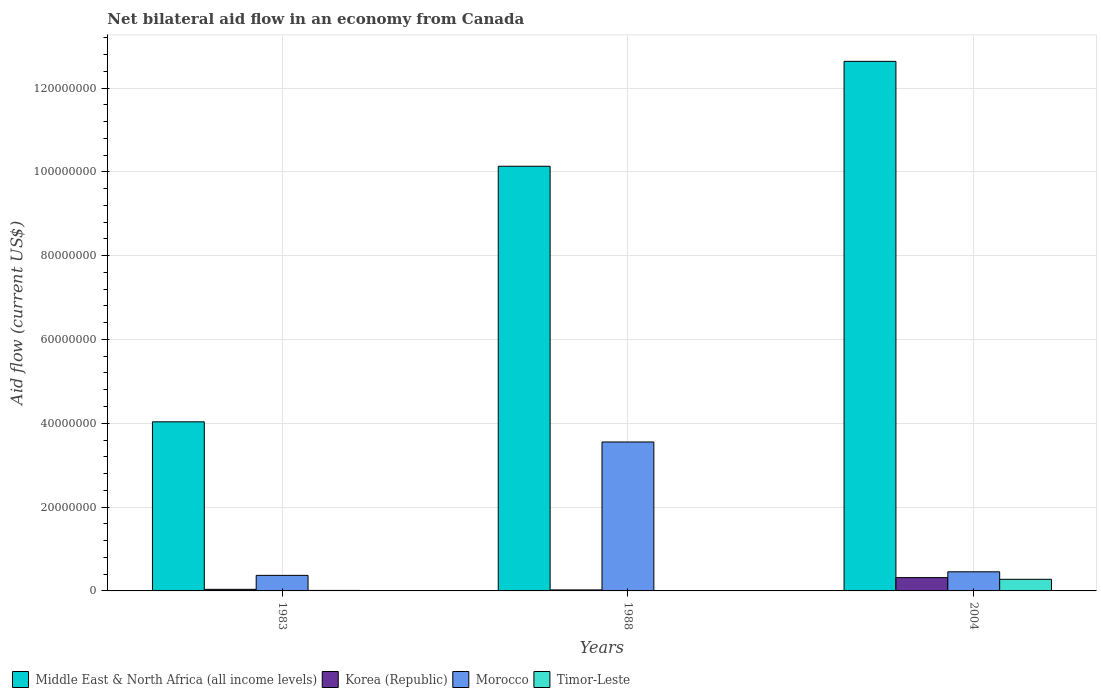How many different coloured bars are there?
Make the answer very short. 4. How many groups of bars are there?
Offer a very short reply. 3. Are the number of bars per tick equal to the number of legend labels?
Your answer should be compact. Yes. How many bars are there on the 1st tick from the right?
Provide a succinct answer. 4. What is the label of the 1st group of bars from the left?
Offer a terse response. 1983. What is the net bilateral aid flow in Korea (Republic) in 2004?
Your answer should be very brief. 3.18e+06. Across all years, what is the maximum net bilateral aid flow in Korea (Republic)?
Offer a terse response. 3.18e+06. What is the total net bilateral aid flow in Korea (Republic) in the graph?
Keep it short and to the point. 3.80e+06. What is the difference between the net bilateral aid flow in Morocco in 1983 and that in 1988?
Keep it short and to the point. -3.18e+07. What is the difference between the net bilateral aid flow in Timor-Leste in 1983 and the net bilateral aid flow in Korea (Republic) in 2004?
Your answer should be compact. -3.06e+06. What is the average net bilateral aid flow in Korea (Republic) per year?
Your answer should be compact. 1.27e+06. In the year 1988, what is the difference between the net bilateral aid flow in Middle East & North Africa (all income levels) and net bilateral aid flow in Morocco?
Your answer should be very brief. 6.58e+07. What is the ratio of the net bilateral aid flow in Middle East & North Africa (all income levels) in 1983 to that in 1988?
Offer a very short reply. 0.4. Is the net bilateral aid flow in Timor-Leste in 1988 less than that in 2004?
Keep it short and to the point. Yes. Is the difference between the net bilateral aid flow in Middle East & North Africa (all income levels) in 1983 and 1988 greater than the difference between the net bilateral aid flow in Morocco in 1983 and 1988?
Provide a succinct answer. No. What is the difference between the highest and the second highest net bilateral aid flow in Morocco?
Keep it short and to the point. 3.10e+07. What is the difference between the highest and the lowest net bilateral aid flow in Timor-Leste?
Your response must be concise. 2.75e+06. Is the sum of the net bilateral aid flow in Korea (Republic) in 1983 and 2004 greater than the maximum net bilateral aid flow in Middle East & North Africa (all income levels) across all years?
Your answer should be compact. No. Is it the case that in every year, the sum of the net bilateral aid flow in Korea (Republic) and net bilateral aid flow in Morocco is greater than the sum of net bilateral aid flow in Middle East & North Africa (all income levels) and net bilateral aid flow in Timor-Leste?
Ensure brevity in your answer.  No. What does the 1st bar from the left in 1988 represents?
Ensure brevity in your answer.  Middle East & North Africa (all income levels). What does the 1st bar from the right in 1988 represents?
Provide a succinct answer. Timor-Leste. Is it the case that in every year, the sum of the net bilateral aid flow in Morocco and net bilateral aid flow in Timor-Leste is greater than the net bilateral aid flow in Middle East & North Africa (all income levels)?
Ensure brevity in your answer.  No. How many bars are there?
Offer a terse response. 12. Are all the bars in the graph horizontal?
Give a very brief answer. No. What is the difference between two consecutive major ticks on the Y-axis?
Keep it short and to the point. 2.00e+07. Are the values on the major ticks of Y-axis written in scientific E-notation?
Give a very brief answer. No. Does the graph contain any zero values?
Provide a short and direct response. No. Does the graph contain grids?
Your answer should be very brief. Yes. Where does the legend appear in the graph?
Your response must be concise. Bottom left. How many legend labels are there?
Keep it short and to the point. 4. How are the legend labels stacked?
Provide a succinct answer. Horizontal. What is the title of the graph?
Offer a terse response. Net bilateral aid flow in an economy from Canada. What is the Aid flow (current US$) in Middle East & North Africa (all income levels) in 1983?
Keep it short and to the point. 4.04e+07. What is the Aid flow (current US$) in Morocco in 1983?
Make the answer very short. 3.71e+06. What is the Aid flow (current US$) of Middle East & North Africa (all income levels) in 1988?
Provide a succinct answer. 1.01e+08. What is the Aid flow (current US$) in Korea (Republic) in 1988?
Your answer should be very brief. 2.40e+05. What is the Aid flow (current US$) of Morocco in 1988?
Your answer should be very brief. 3.55e+07. What is the Aid flow (current US$) of Middle East & North Africa (all income levels) in 2004?
Provide a short and direct response. 1.26e+08. What is the Aid flow (current US$) in Korea (Republic) in 2004?
Make the answer very short. 3.18e+06. What is the Aid flow (current US$) in Morocco in 2004?
Give a very brief answer. 4.56e+06. What is the Aid flow (current US$) in Timor-Leste in 2004?
Provide a succinct answer. 2.77e+06. Across all years, what is the maximum Aid flow (current US$) of Middle East & North Africa (all income levels)?
Keep it short and to the point. 1.26e+08. Across all years, what is the maximum Aid flow (current US$) of Korea (Republic)?
Give a very brief answer. 3.18e+06. Across all years, what is the maximum Aid flow (current US$) of Morocco?
Provide a succinct answer. 3.55e+07. Across all years, what is the maximum Aid flow (current US$) in Timor-Leste?
Your answer should be very brief. 2.77e+06. Across all years, what is the minimum Aid flow (current US$) in Middle East & North Africa (all income levels)?
Keep it short and to the point. 4.04e+07. Across all years, what is the minimum Aid flow (current US$) of Morocco?
Your answer should be very brief. 3.71e+06. What is the total Aid flow (current US$) of Middle East & North Africa (all income levels) in the graph?
Give a very brief answer. 2.68e+08. What is the total Aid flow (current US$) in Korea (Republic) in the graph?
Ensure brevity in your answer.  3.80e+06. What is the total Aid flow (current US$) of Morocco in the graph?
Your answer should be very brief. 4.38e+07. What is the total Aid flow (current US$) of Timor-Leste in the graph?
Your response must be concise. 2.91e+06. What is the difference between the Aid flow (current US$) of Middle East & North Africa (all income levels) in 1983 and that in 1988?
Your response must be concise. -6.10e+07. What is the difference between the Aid flow (current US$) of Korea (Republic) in 1983 and that in 1988?
Keep it short and to the point. 1.40e+05. What is the difference between the Aid flow (current US$) in Morocco in 1983 and that in 1988?
Offer a very short reply. -3.18e+07. What is the difference between the Aid flow (current US$) in Middle East & North Africa (all income levels) in 1983 and that in 2004?
Give a very brief answer. -8.60e+07. What is the difference between the Aid flow (current US$) of Korea (Republic) in 1983 and that in 2004?
Offer a very short reply. -2.80e+06. What is the difference between the Aid flow (current US$) of Morocco in 1983 and that in 2004?
Offer a terse response. -8.50e+05. What is the difference between the Aid flow (current US$) in Timor-Leste in 1983 and that in 2004?
Provide a succinct answer. -2.65e+06. What is the difference between the Aid flow (current US$) of Middle East & North Africa (all income levels) in 1988 and that in 2004?
Make the answer very short. -2.50e+07. What is the difference between the Aid flow (current US$) of Korea (Republic) in 1988 and that in 2004?
Provide a short and direct response. -2.94e+06. What is the difference between the Aid flow (current US$) in Morocco in 1988 and that in 2004?
Provide a succinct answer. 3.10e+07. What is the difference between the Aid flow (current US$) of Timor-Leste in 1988 and that in 2004?
Your answer should be compact. -2.75e+06. What is the difference between the Aid flow (current US$) in Middle East & North Africa (all income levels) in 1983 and the Aid flow (current US$) in Korea (Republic) in 1988?
Provide a short and direct response. 4.01e+07. What is the difference between the Aid flow (current US$) of Middle East & North Africa (all income levels) in 1983 and the Aid flow (current US$) of Morocco in 1988?
Offer a very short reply. 4.81e+06. What is the difference between the Aid flow (current US$) in Middle East & North Africa (all income levels) in 1983 and the Aid flow (current US$) in Timor-Leste in 1988?
Keep it short and to the point. 4.03e+07. What is the difference between the Aid flow (current US$) in Korea (Republic) in 1983 and the Aid flow (current US$) in Morocco in 1988?
Your answer should be very brief. -3.52e+07. What is the difference between the Aid flow (current US$) of Korea (Republic) in 1983 and the Aid flow (current US$) of Timor-Leste in 1988?
Keep it short and to the point. 3.60e+05. What is the difference between the Aid flow (current US$) of Morocco in 1983 and the Aid flow (current US$) of Timor-Leste in 1988?
Ensure brevity in your answer.  3.69e+06. What is the difference between the Aid flow (current US$) of Middle East & North Africa (all income levels) in 1983 and the Aid flow (current US$) of Korea (Republic) in 2004?
Keep it short and to the point. 3.72e+07. What is the difference between the Aid flow (current US$) in Middle East & North Africa (all income levels) in 1983 and the Aid flow (current US$) in Morocco in 2004?
Keep it short and to the point. 3.58e+07. What is the difference between the Aid flow (current US$) of Middle East & North Africa (all income levels) in 1983 and the Aid flow (current US$) of Timor-Leste in 2004?
Provide a short and direct response. 3.76e+07. What is the difference between the Aid flow (current US$) in Korea (Republic) in 1983 and the Aid flow (current US$) in Morocco in 2004?
Your answer should be compact. -4.18e+06. What is the difference between the Aid flow (current US$) of Korea (Republic) in 1983 and the Aid flow (current US$) of Timor-Leste in 2004?
Your answer should be compact. -2.39e+06. What is the difference between the Aid flow (current US$) of Morocco in 1983 and the Aid flow (current US$) of Timor-Leste in 2004?
Provide a short and direct response. 9.40e+05. What is the difference between the Aid flow (current US$) in Middle East & North Africa (all income levels) in 1988 and the Aid flow (current US$) in Korea (Republic) in 2004?
Provide a succinct answer. 9.82e+07. What is the difference between the Aid flow (current US$) in Middle East & North Africa (all income levels) in 1988 and the Aid flow (current US$) in Morocco in 2004?
Keep it short and to the point. 9.68e+07. What is the difference between the Aid flow (current US$) in Middle East & North Africa (all income levels) in 1988 and the Aid flow (current US$) in Timor-Leste in 2004?
Make the answer very short. 9.86e+07. What is the difference between the Aid flow (current US$) of Korea (Republic) in 1988 and the Aid flow (current US$) of Morocco in 2004?
Your answer should be compact. -4.32e+06. What is the difference between the Aid flow (current US$) in Korea (Republic) in 1988 and the Aid flow (current US$) in Timor-Leste in 2004?
Keep it short and to the point. -2.53e+06. What is the difference between the Aid flow (current US$) of Morocco in 1988 and the Aid flow (current US$) of Timor-Leste in 2004?
Keep it short and to the point. 3.28e+07. What is the average Aid flow (current US$) in Middle East & North Africa (all income levels) per year?
Keep it short and to the point. 8.93e+07. What is the average Aid flow (current US$) in Korea (Republic) per year?
Your answer should be very brief. 1.27e+06. What is the average Aid flow (current US$) of Morocco per year?
Provide a succinct answer. 1.46e+07. What is the average Aid flow (current US$) in Timor-Leste per year?
Provide a short and direct response. 9.70e+05. In the year 1983, what is the difference between the Aid flow (current US$) in Middle East & North Africa (all income levels) and Aid flow (current US$) in Korea (Republic)?
Make the answer very short. 4.00e+07. In the year 1983, what is the difference between the Aid flow (current US$) in Middle East & North Africa (all income levels) and Aid flow (current US$) in Morocco?
Give a very brief answer. 3.66e+07. In the year 1983, what is the difference between the Aid flow (current US$) in Middle East & North Africa (all income levels) and Aid flow (current US$) in Timor-Leste?
Provide a succinct answer. 4.02e+07. In the year 1983, what is the difference between the Aid flow (current US$) of Korea (Republic) and Aid flow (current US$) of Morocco?
Offer a terse response. -3.33e+06. In the year 1983, what is the difference between the Aid flow (current US$) in Morocco and Aid flow (current US$) in Timor-Leste?
Provide a succinct answer. 3.59e+06. In the year 1988, what is the difference between the Aid flow (current US$) of Middle East & North Africa (all income levels) and Aid flow (current US$) of Korea (Republic)?
Offer a very short reply. 1.01e+08. In the year 1988, what is the difference between the Aid flow (current US$) of Middle East & North Africa (all income levels) and Aid flow (current US$) of Morocco?
Provide a succinct answer. 6.58e+07. In the year 1988, what is the difference between the Aid flow (current US$) in Middle East & North Africa (all income levels) and Aid flow (current US$) in Timor-Leste?
Keep it short and to the point. 1.01e+08. In the year 1988, what is the difference between the Aid flow (current US$) in Korea (Republic) and Aid flow (current US$) in Morocco?
Provide a succinct answer. -3.53e+07. In the year 1988, what is the difference between the Aid flow (current US$) in Korea (Republic) and Aid flow (current US$) in Timor-Leste?
Your answer should be compact. 2.20e+05. In the year 1988, what is the difference between the Aid flow (current US$) of Morocco and Aid flow (current US$) of Timor-Leste?
Provide a short and direct response. 3.55e+07. In the year 2004, what is the difference between the Aid flow (current US$) in Middle East & North Africa (all income levels) and Aid flow (current US$) in Korea (Republic)?
Make the answer very short. 1.23e+08. In the year 2004, what is the difference between the Aid flow (current US$) in Middle East & North Africa (all income levels) and Aid flow (current US$) in Morocco?
Your response must be concise. 1.22e+08. In the year 2004, what is the difference between the Aid flow (current US$) of Middle East & North Africa (all income levels) and Aid flow (current US$) of Timor-Leste?
Your answer should be very brief. 1.24e+08. In the year 2004, what is the difference between the Aid flow (current US$) of Korea (Republic) and Aid flow (current US$) of Morocco?
Ensure brevity in your answer.  -1.38e+06. In the year 2004, what is the difference between the Aid flow (current US$) in Morocco and Aid flow (current US$) in Timor-Leste?
Your answer should be very brief. 1.79e+06. What is the ratio of the Aid flow (current US$) in Middle East & North Africa (all income levels) in 1983 to that in 1988?
Your answer should be very brief. 0.4. What is the ratio of the Aid flow (current US$) of Korea (Republic) in 1983 to that in 1988?
Your answer should be compact. 1.58. What is the ratio of the Aid flow (current US$) of Morocco in 1983 to that in 1988?
Give a very brief answer. 0.1. What is the ratio of the Aid flow (current US$) of Middle East & North Africa (all income levels) in 1983 to that in 2004?
Offer a very short reply. 0.32. What is the ratio of the Aid flow (current US$) of Korea (Republic) in 1983 to that in 2004?
Your response must be concise. 0.12. What is the ratio of the Aid flow (current US$) in Morocco in 1983 to that in 2004?
Keep it short and to the point. 0.81. What is the ratio of the Aid flow (current US$) of Timor-Leste in 1983 to that in 2004?
Make the answer very short. 0.04. What is the ratio of the Aid flow (current US$) in Middle East & North Africa (all income levels) in 1988 to that in 2004?
Your response must be concise. 0.8. What is the ratio of the Aid flow (current US$) in Korea (Republic) in 1988 to that in 2004?
Your answer should be very brief. 0.08. What is the ratio of the Aid flow (current US$) of Morocco in 1988 to that in 2004?
Provide a short and direct response. 7.79. What is the ratio of the Aid flow (current US$) of Timor-Leste in 1988 to that in 2004?
Your response must be concise. 0.01. What is the difference between the highest and the second highest Aid flow (current US$) of Middle East & North Africa (all income levels)?
Provide a short and direct response. 2.50e+07. What is the difference between the highest and the second highest Aid flow (current US$) of Korea (Republic)?
Keep it short and to the point. 2.80e+06. What is the difference between the highest and the second highest Aid flow (current US$) of Morocco?
Provide a succinct answer. 3.10e+07. What is the difference between the highest and the second highest Aid flow (current US$) of Timor-Leste?
Your answer should be very brief. 2.65e+06. What is the difference between the highest and the lowest Aid flow (current US$) of Middle East & North Africa (all income levels)?
Give a very brief answer. 8.60e+07. What is the difference between the highest and the lowest Aid flow (current US$) in Korea (Republic)?
Your answer should be compact. 2.94e+06. What is the difference between the highest and the lowest Aid flow (current US$) in Morocco?
Your response must be concise. 3.18e+07. What is the difference between the highest and the lowest Aid flow (current US$) of Timor-Leste?
Provide a succinct answer. 2.75e+06. 